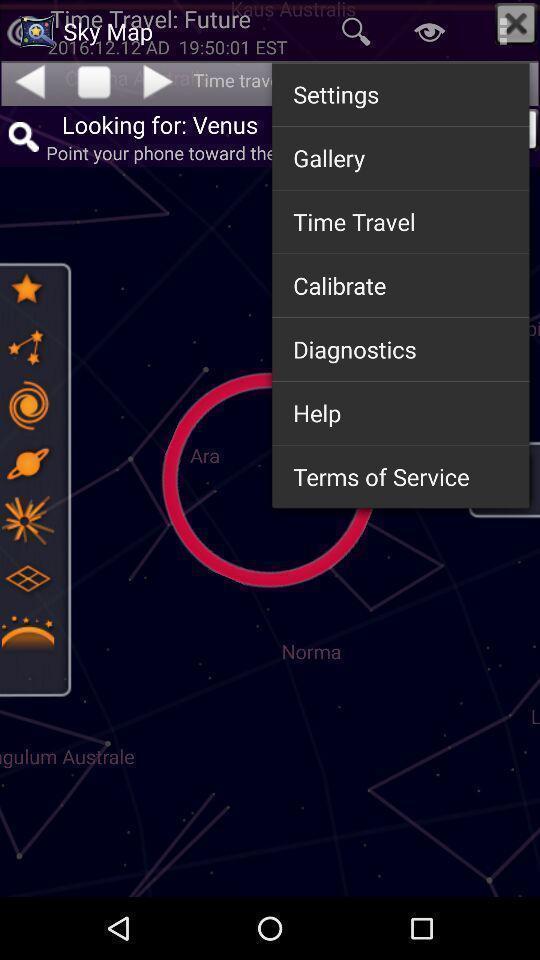What can you discern from this picture? Pop-up for different settings options on astrology app. 